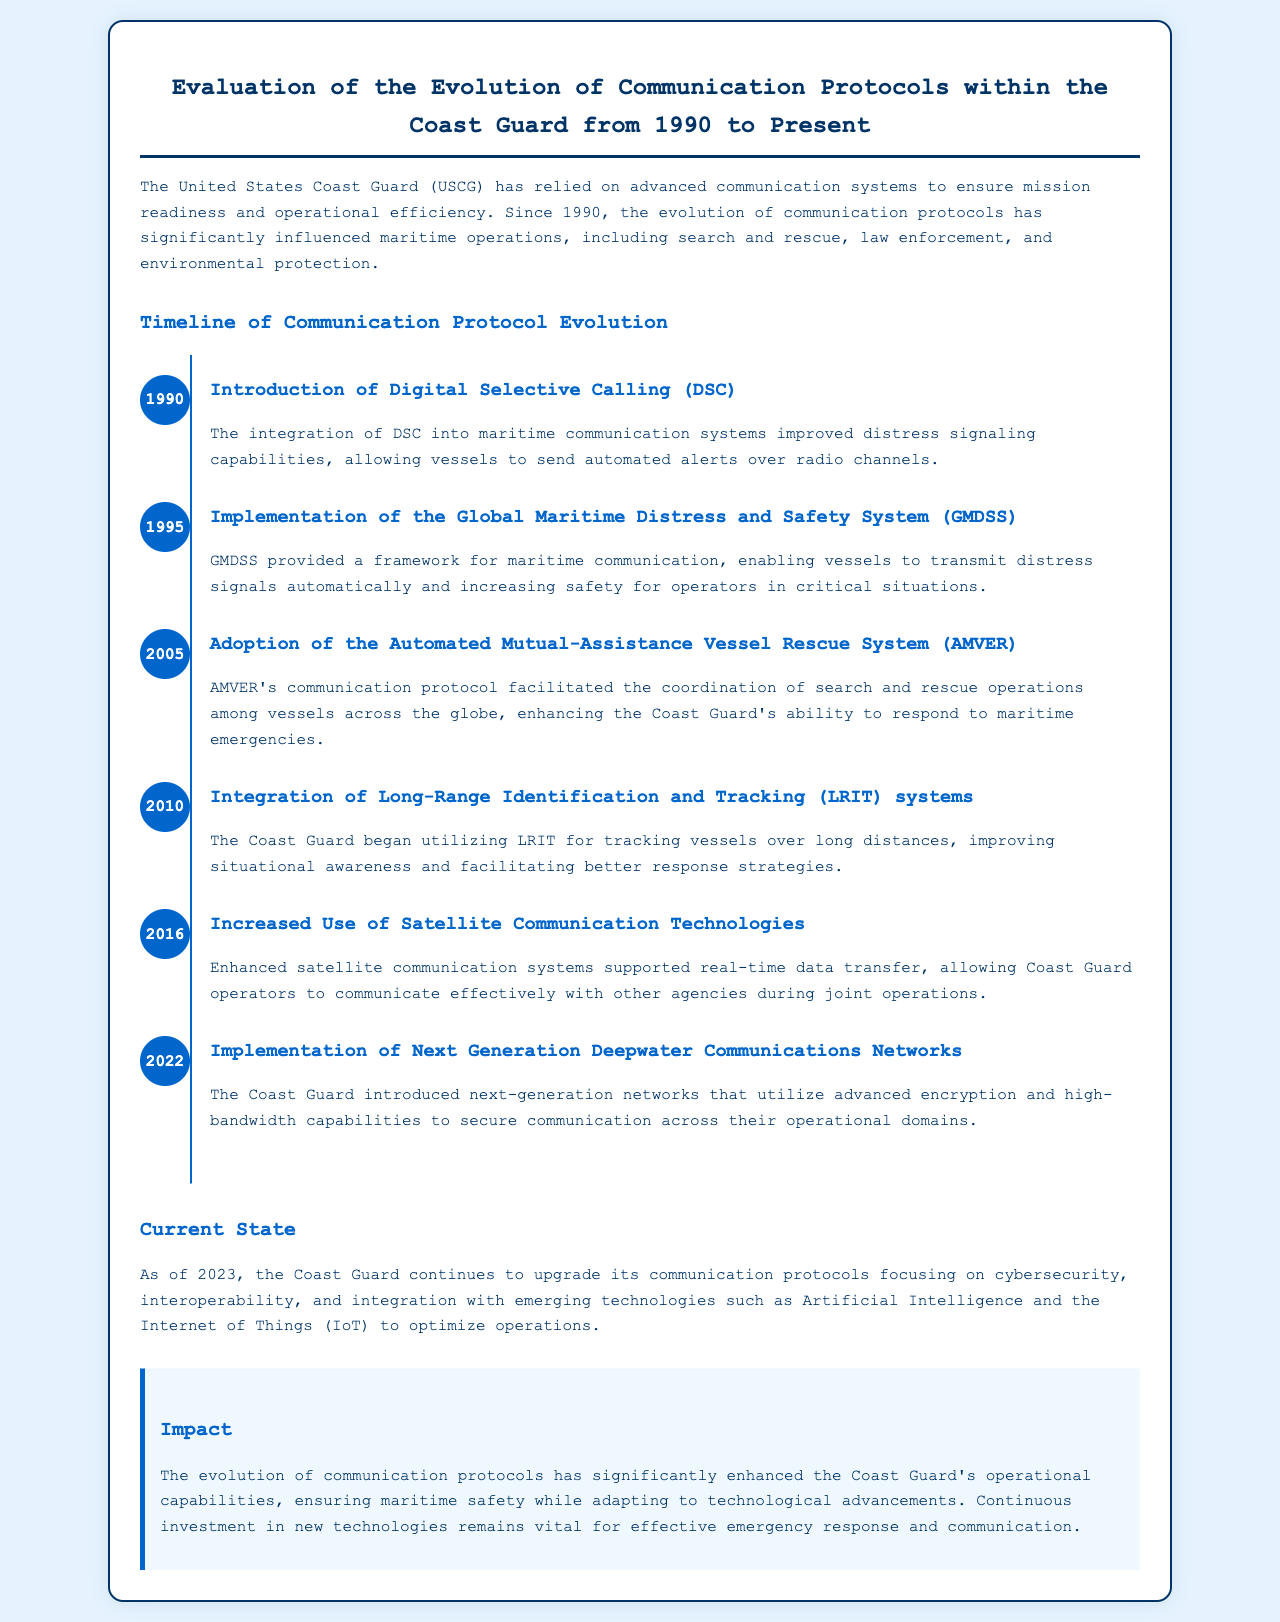What communication system was introduced in 1990? The document states that the introduction of Digital Selective Calling (DSC) occurred in 1990.
Answer: Digital Selective Calling (DSC) What year was the Global Maritime Distress and Safety System implemented? The document mentions that the Global Maritime Distress and Safety System (GMDSS) was implemented in 1995.
Answer: 1995 What does AMVER stand for? The document references the Automated Mutual-Assistance Vessel Rescue System as AMVER.
Answer: Automated Mutual-Assistance Vessel Rescue System What major technological advancement was integrated into Coast Guard communication systems in 2016? Enhanced satellite communication technologies were noted as a major advancement integrated in 2016.
Answer: Satellite communication technologies How has the Coast Guard's communication protocols focused as of 2023? The current focus of the Coast Guard's communication protocol is on cybersecurity, interoperability, and integration with emerging technologies.
Answer: Cybersecurity, interoperability, and integration with emerging technologies What is a significant benefit of integrating DSC into maritime communication? The document states that DSC improved distress signaling capabilities, allowing automated alerts over radio channels.
Answer: Improved distress signaling capabilities How many years separate the introduction of DSC and the implementation of GMDSS? The difference between 1990 and 1995 is 5 years.
Answer: 5 years What has been the impact of the evolution of communication protocols according to the report? The report indicates that the evolution enhances operational capabilities and maritime safety.
Answer: Enhanced operational capabilities and maritime safety 